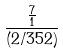Convert formula to latex. <formula><loc_0><loc_0><loc_500><loc_500>\frac { \frac { 7 } { 1 } } { ( 2 / 3 5 2 ) }</formula> 